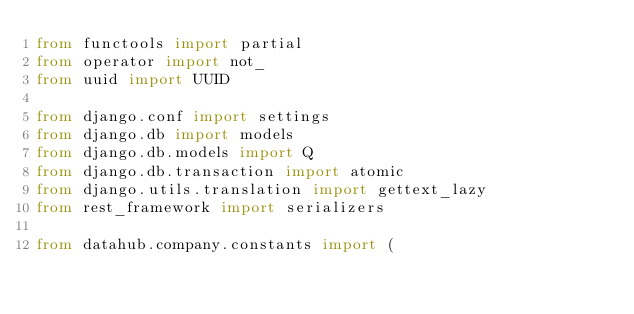<code> <loc_0><loc_0><loc_500><loc_500><_Python_>from functools import partial
from operator import not_
from uuid import UUID

from django.conf import settings
from django.db import models
from django.db.models import Q
from django.db.transaction import atomic
from django.utils.translation import gettext_lazy
from rest_framework import serializers

from datahub.company.constants import (</code> 